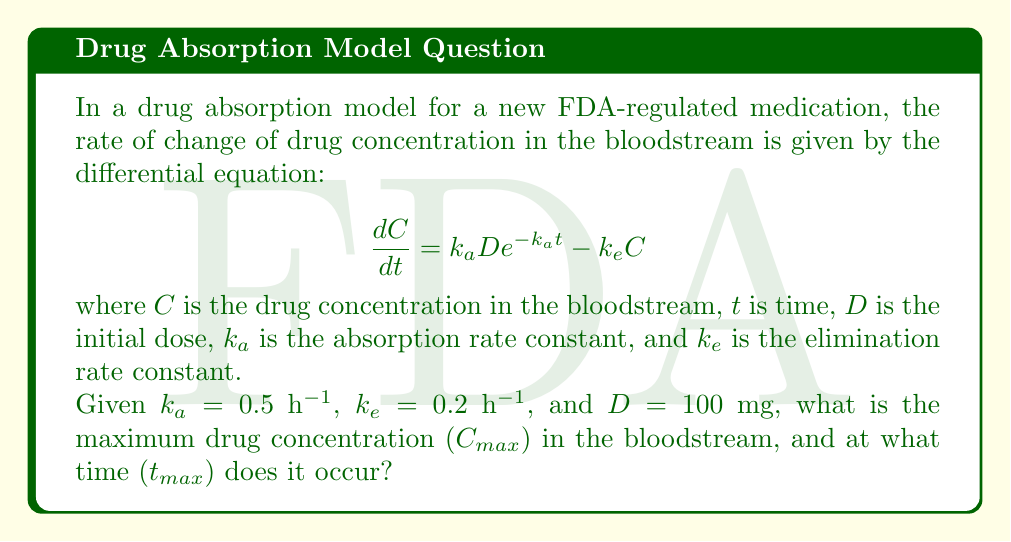What is the answer to this math problem? To solve this problem, we'll follow these steps:

1) The maximum concentration occurs when $\frac{dC}{dt} = 0$. At this point:

   $$k_a D e^{-k_a t} - k_e C = 0$$

2) Rearranging this equation:

   $$C = \frac{k_a D e^{-k_a t}}{k_e}$$

3) To find $t_{max}$, we differentiate $C$ with respect to $t$ and set it to zero:

   $$\frac{dC}{dt} = \frac{-k_a^2 D e^{-k_a t}}{k_e} = 0$$

4) This is only true when $t$ approaches infinity, which isn't practical. Instead, we can find $t_{max}$ by setting the original differential equation to zero:

   $$k_a D e^{-k_a t} = k_e C$$

5) Taking the natural log of both sides:

   $$\ln(k_a D) - k_a t = \ln(k_e C)$$

6) Solving for $t$:

   $$t_{max} = \frac{\ln(k_a/k_e)}{k_a - k_e}$$

7) Substituting the given values:

   $$t_{max} = \frac{\ln(0.5/0.2)}{0.5 - 0.2} = 2.47 \text{ hours}$$

8) To find $C_{max}$, we substitute $t_{max}$ back into the equation from step 2:

   $$C_{max} = \frac{k_a D e^{-k_a t_{max}}}{k_e}$$

9) Substituting the values:

   $$C_{max} = \frac{0.5 \cdot 100 \cdot e^{-0.5 \cdot 2.47}}{0.2} = 75.8 \text{ mg/L}$$

Therefore, the maximum concentration is 75.8 mg/L and occurs at 2.47 hours after administration.
Answer: $C_{max} = 75.8$ mg/L, $t_{max} = 2.47$ hours 